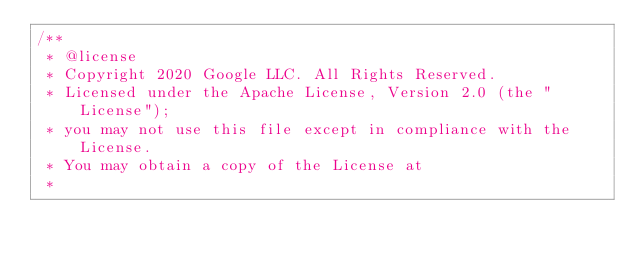<code> <loc_0><loc_0><loc_500><loc_500><_TypeScript_>/**
 * @license
 * Copyright 2020 Google LLC. All Rights Reserved.
 * Licensed under the Apache License, Version 2.0 (the "License");
 * you may not use this file except in compliance with the License.
 * You may obtain a copy of the License at
 *</code> 